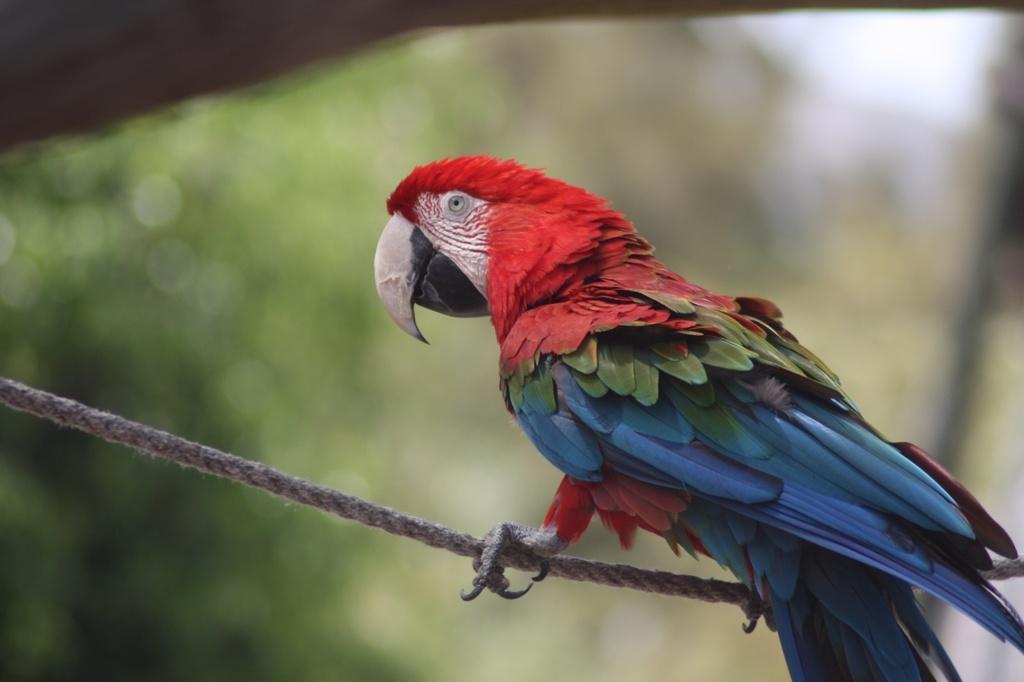Please provide a concise description of this image. In this image I can see a beautiful parrot is standing on the rope, it is in red, blue and green color. 